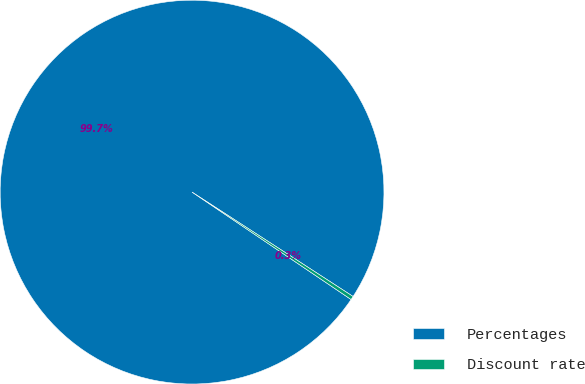Convert chart to OTSL. <chart><loc_0><loc_0><loc_500><loc_500><pie_chart><fcel>Percentages<fcel>Discount rate<nl><fcel>99.7%<fcel>0.3%<nl></chart> 